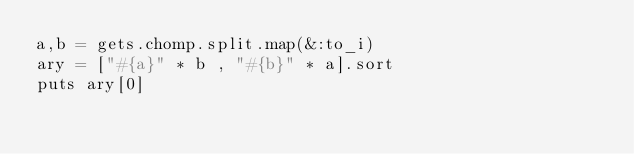Convert code to text. <code><loc_0><loc_0><loc_500><loc_500><_Ruby_>a,b = gets.chomp.split.map(&:to_i)
ary = ["#{a}" * b , "#{b}" * a].sort
puts ary[0]</code> 